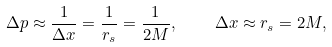<formula> <loc_0><loc_0><loc_500><loc_500>\Delta p \approx \frac { 1 } { \Delta x } = \frac { 1 } { r _ { s } } = \frac { 1 } { 2 M } , \quad \Delta x \approx r _ { s } = 2 M ,</formula> 